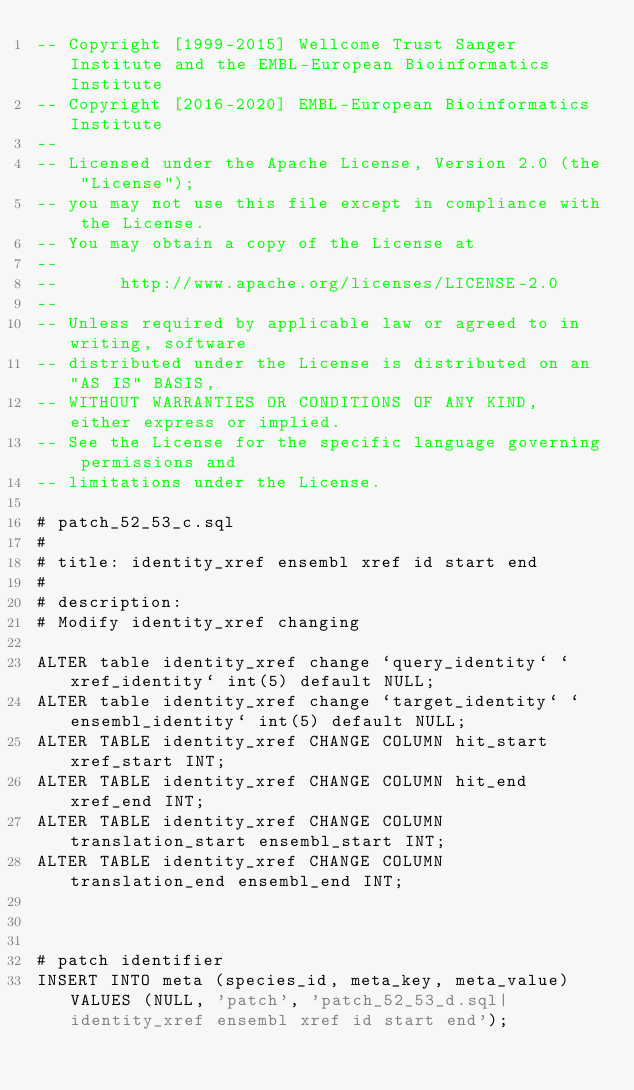Convert code to text. <code><loc_0><loc_0><loc_500><loc_500><_SQL_>-- Copyright [1999-2015] Wellcome Trust Sanger Institute and the EMBL-European Bioinformatics Institute
-- Copyright [2016-2020] EMBL-European Bioinformatics Institute
-- 
-- Licensed under the Apache License, Version 2.0 (the "License");
-- you may not use this file except in compliance with the License.
-- You may obtain a copy of the License at
-- 
--      http://www.apache.org/licenses/LICENSE-2.0
-- 
-- Unless required by applicable law or agreed to in writing, software
-- distributed under the License is distributed on an "AS IS" BASIS,
-- WITHOUT WARRANTIES OR CONDITIONS OF ANY KIND, either express or implied.
-- See the License for the specific language governing permissions and
-- limitations under the License.

# patch_52_53_c.sql
#
# title: identity_xref ensembl xref id start end 
#
# description:
# Modify identity_xref changing 

ALTER table identity_xref change `query_identity` `xref_identity` int(5) default NULL;
ALTER table identity_xref change `target_identity` `ensembl_identity` int(5) default NULL;
ALTER TABLE identity_xref CHANGE COLUMN hit_start xref_start INT;
ALTER TABLE identity_xref CHANGE COLUMN hit_end xref_end INT;
ALTER TABLE identity_xref CHANGE COLUMN translation_start ensembl_start INT;
ALTER TABLE identity_xref CHANGE COLUMN translation_end ensembl_end INT;



# patch identifier
INSERT INTO meta (species_id, meta_key, meta_value) VALUES (NULL, 'patch', 'patch_52_53_d.sql|identity_xref ensembl xref id start end');


</code> 